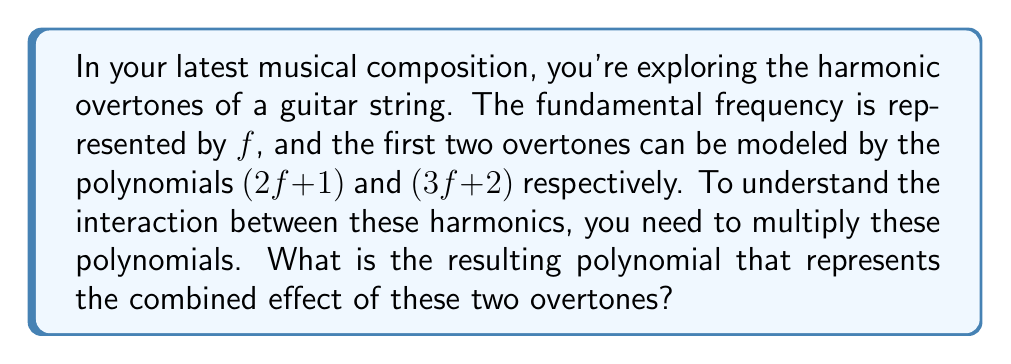What is the answer to this math problem? Let's multiply the two polynomials $(2f + 1)$ and $(3f + 2)$ step by step:

1) First, we'll use the FOIL method (First, Outer, Inner, Last) to multiply these binomials:

   $$(2f + 1)(3f + 2)$$

2) Multiply the First terms: 
   $2f \cdot 3f = 6f^2$

3) Multiply the Outer terms: 
   $2f \cdot 2 = 4f$

4) Multiply the Inner terms: 
   $1 \cdot 3f = 3f$

5) Multiply the Last terms: 
   $1 \cdot 2 = 2$

6) Now, we add all these terms together:

   $$6f^2 + 4f + 3f + 2$$

7) Simplify by combining like terms:

   $$6f^2 + 7f + 2$$

This polynomial represents the combined effect of the first two overtones in your musical composition.
Answer: $6f^2 + 7f + 2$ 